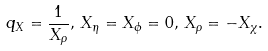Convert formula to latex. <formula><loc_0><loc_0><loc_500><loc_500>q _ { X } = \frac { 1 } { X _ { \rho } } , \, X _ { \eta } = X _ { \phi } = 0 , \, X _ { \rho } = - X _ { \chi } .</formula> 